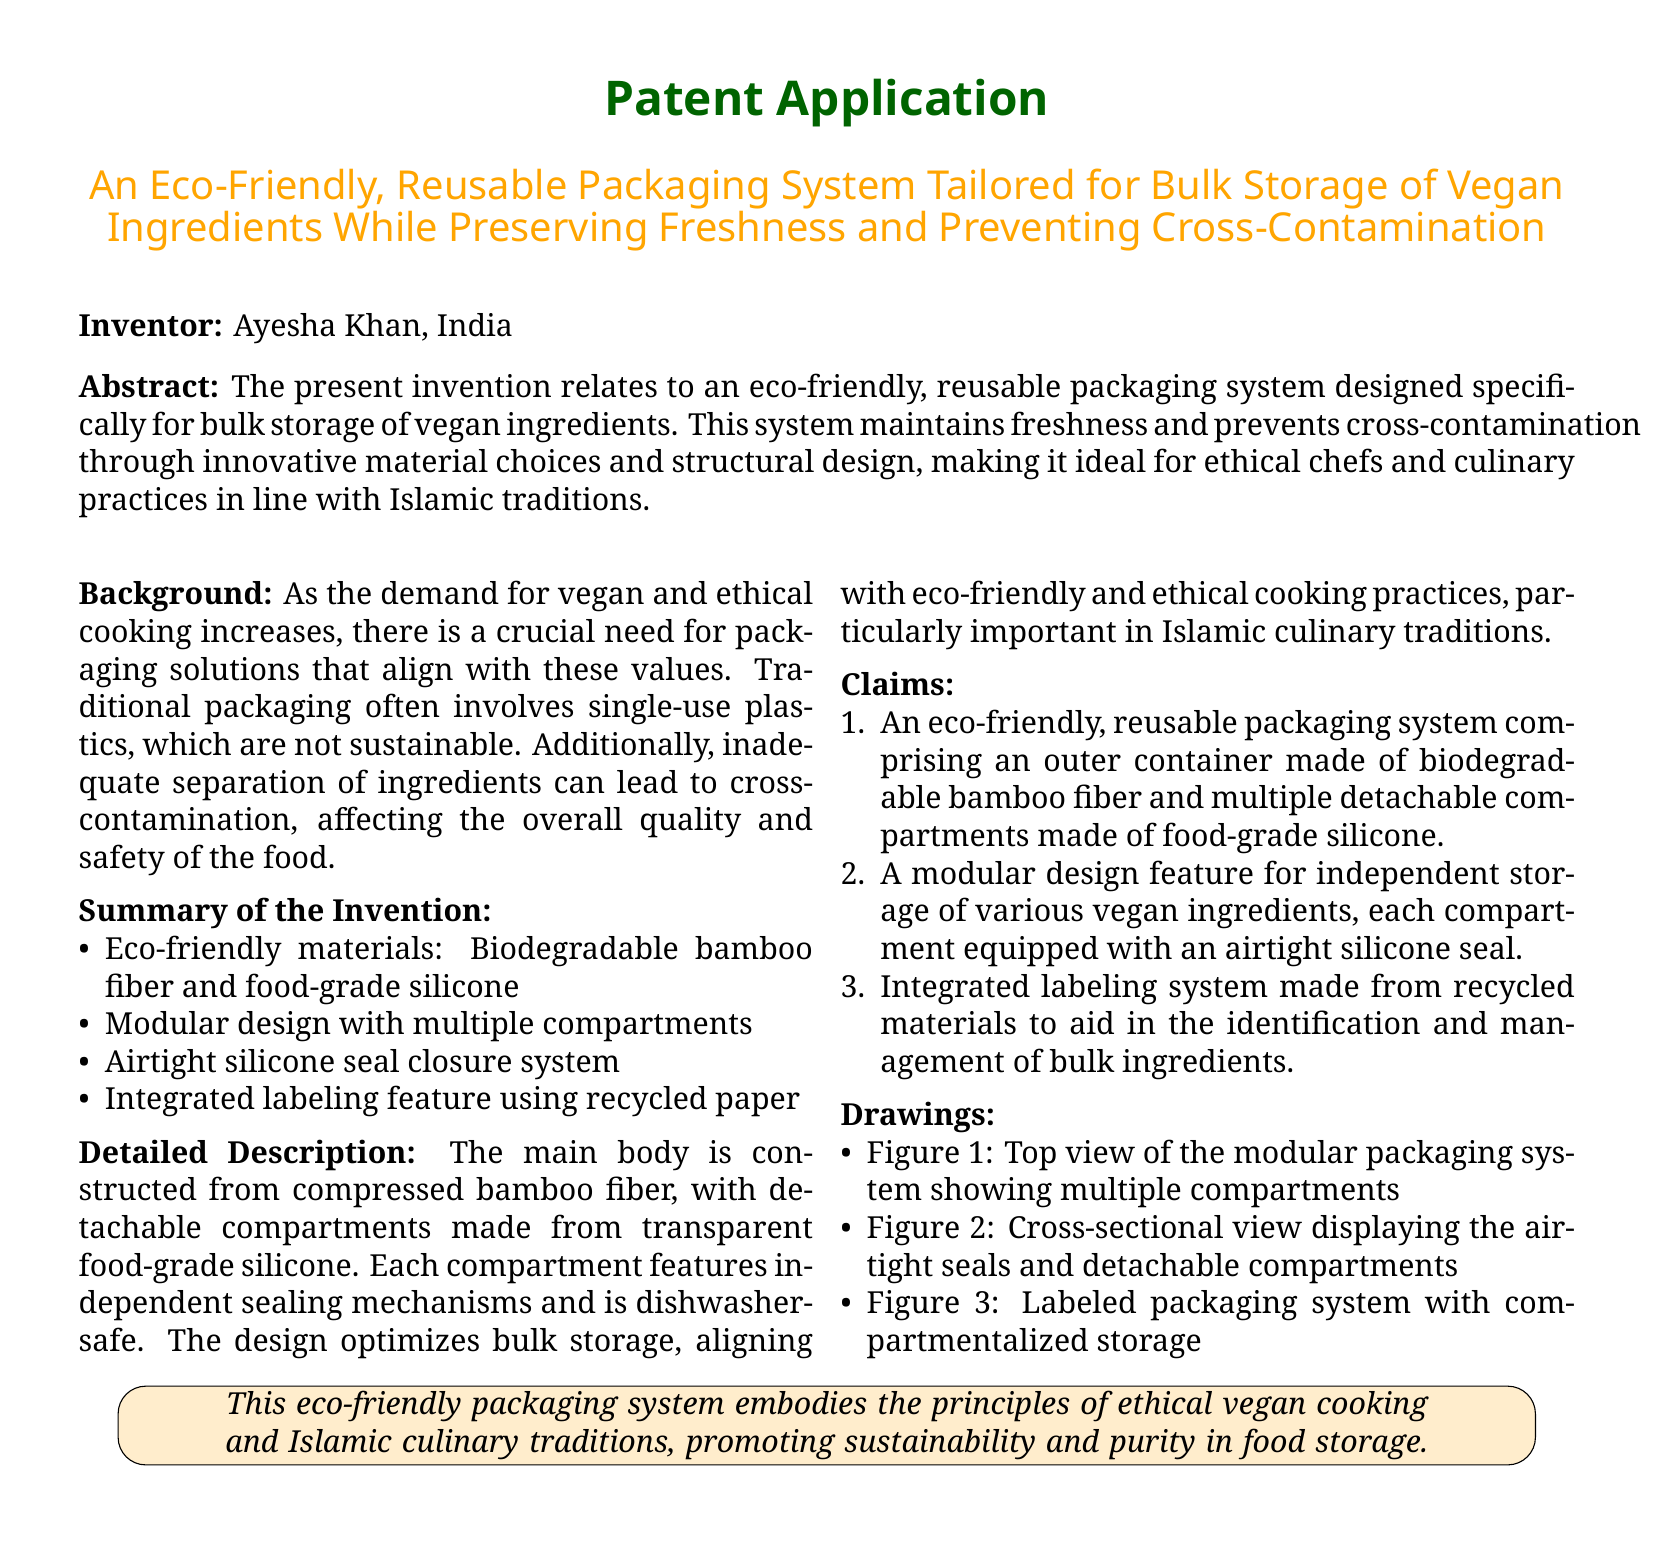What is the name of the inventor? The inventor's name is mentioned in the document as Ayesha Khan.
Answer: Ayesha Khan What materials are used in the packaging system? The document lists biodegradable bamboo fiber and food-grade silicone as the materials used.
Answer: Bamboo fiber, food-grade silicone How many compartments does the packaging system have? The document does not specify an exact number of compartments, but it mentions multiple detachable compartments.
Answer: Multiple compartments What feature prevents cross-contamination in this packaging system? The packaging system maintains freshness and prevents cross-contamination through its independent sealing mechanisms for each compartment.
Answer: Independent sealing mechanisms What is the purpose of the integrated labeling feature? The integrated labeling system is used to aid in the identification and management of bulk ingredients.
Answer: Identification of ingredients What type of packaging does this invention aim to replace? The invention aims to replace traditional single-use plastics which are not sustainable.
Answer: Single-use plastics What culinary traditions does the packaging system align with? The document references that the packaging system aligns with Islamic culinary traditions.
Answer: Islamic culinary traditions Which way is the packaging system described as being dishwasher-safe? Dishwasher-safe is stated in the detailed description section regarding the detachable compartments made of silicone.
Answer: Detachable compartments What is the primary focus of the patent application? The primary focus is on creating an eco-friendly, reusable packaging system tailored for bulk storage of vegan ingredients.
Answer: Eco-friendly, reusable packaging system 